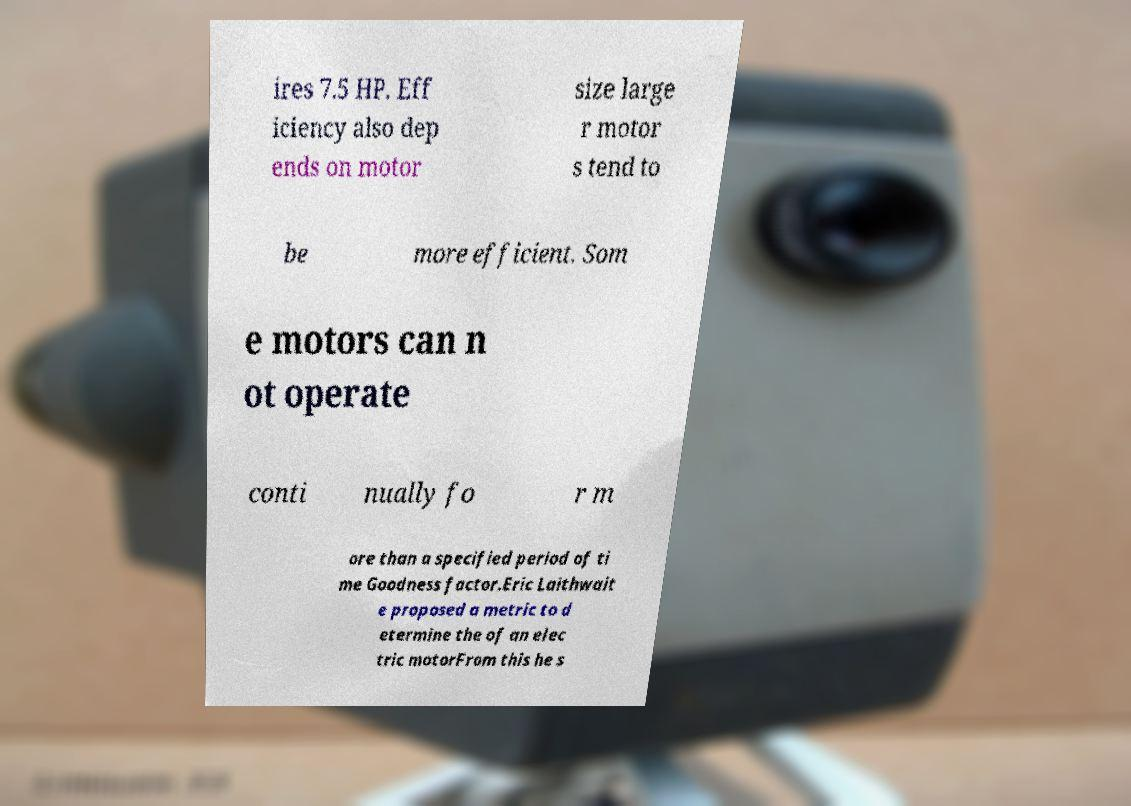Please identify and transcribe the text found in this image. ires 7.5 HP. Eff iciency also dep ends on motor size large r motor s tend to be more efficient. Som e motors can n ot operate conti nually fo r m ore than a specified period of ti me Goodness factor.Eric Laithwait e proposed a metric to d etermine the of an elec tric motorFrom this he s 